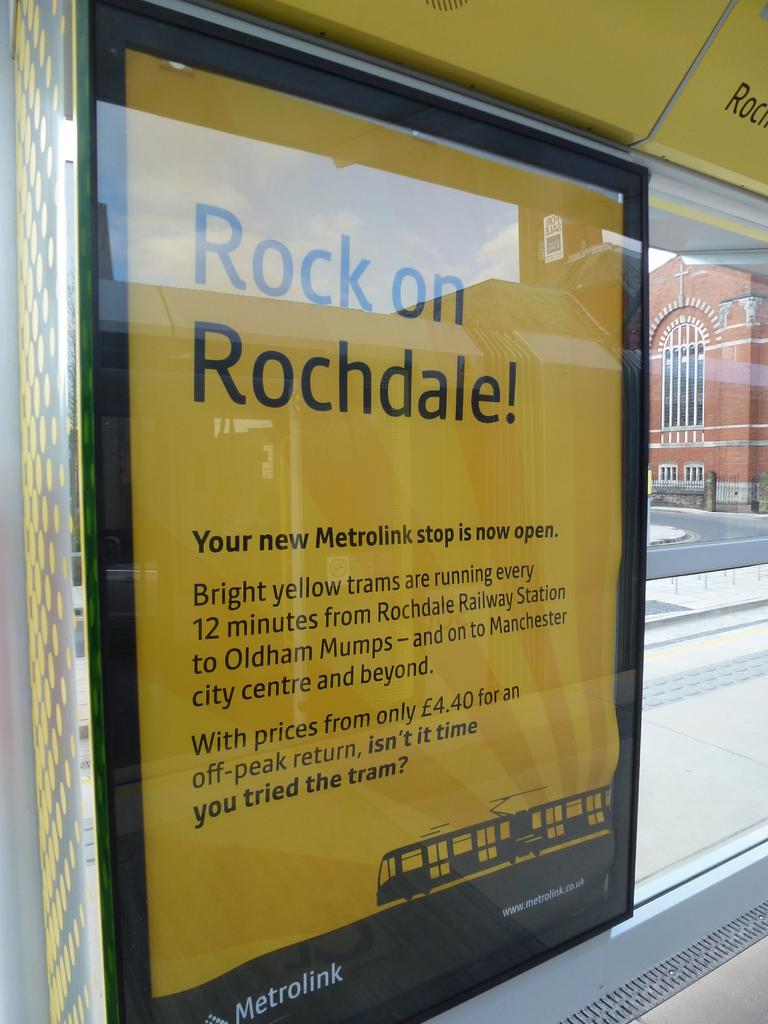<image>
Offer a succinct explanation of the picture presented. a sign for something that is called rock on rochdale 